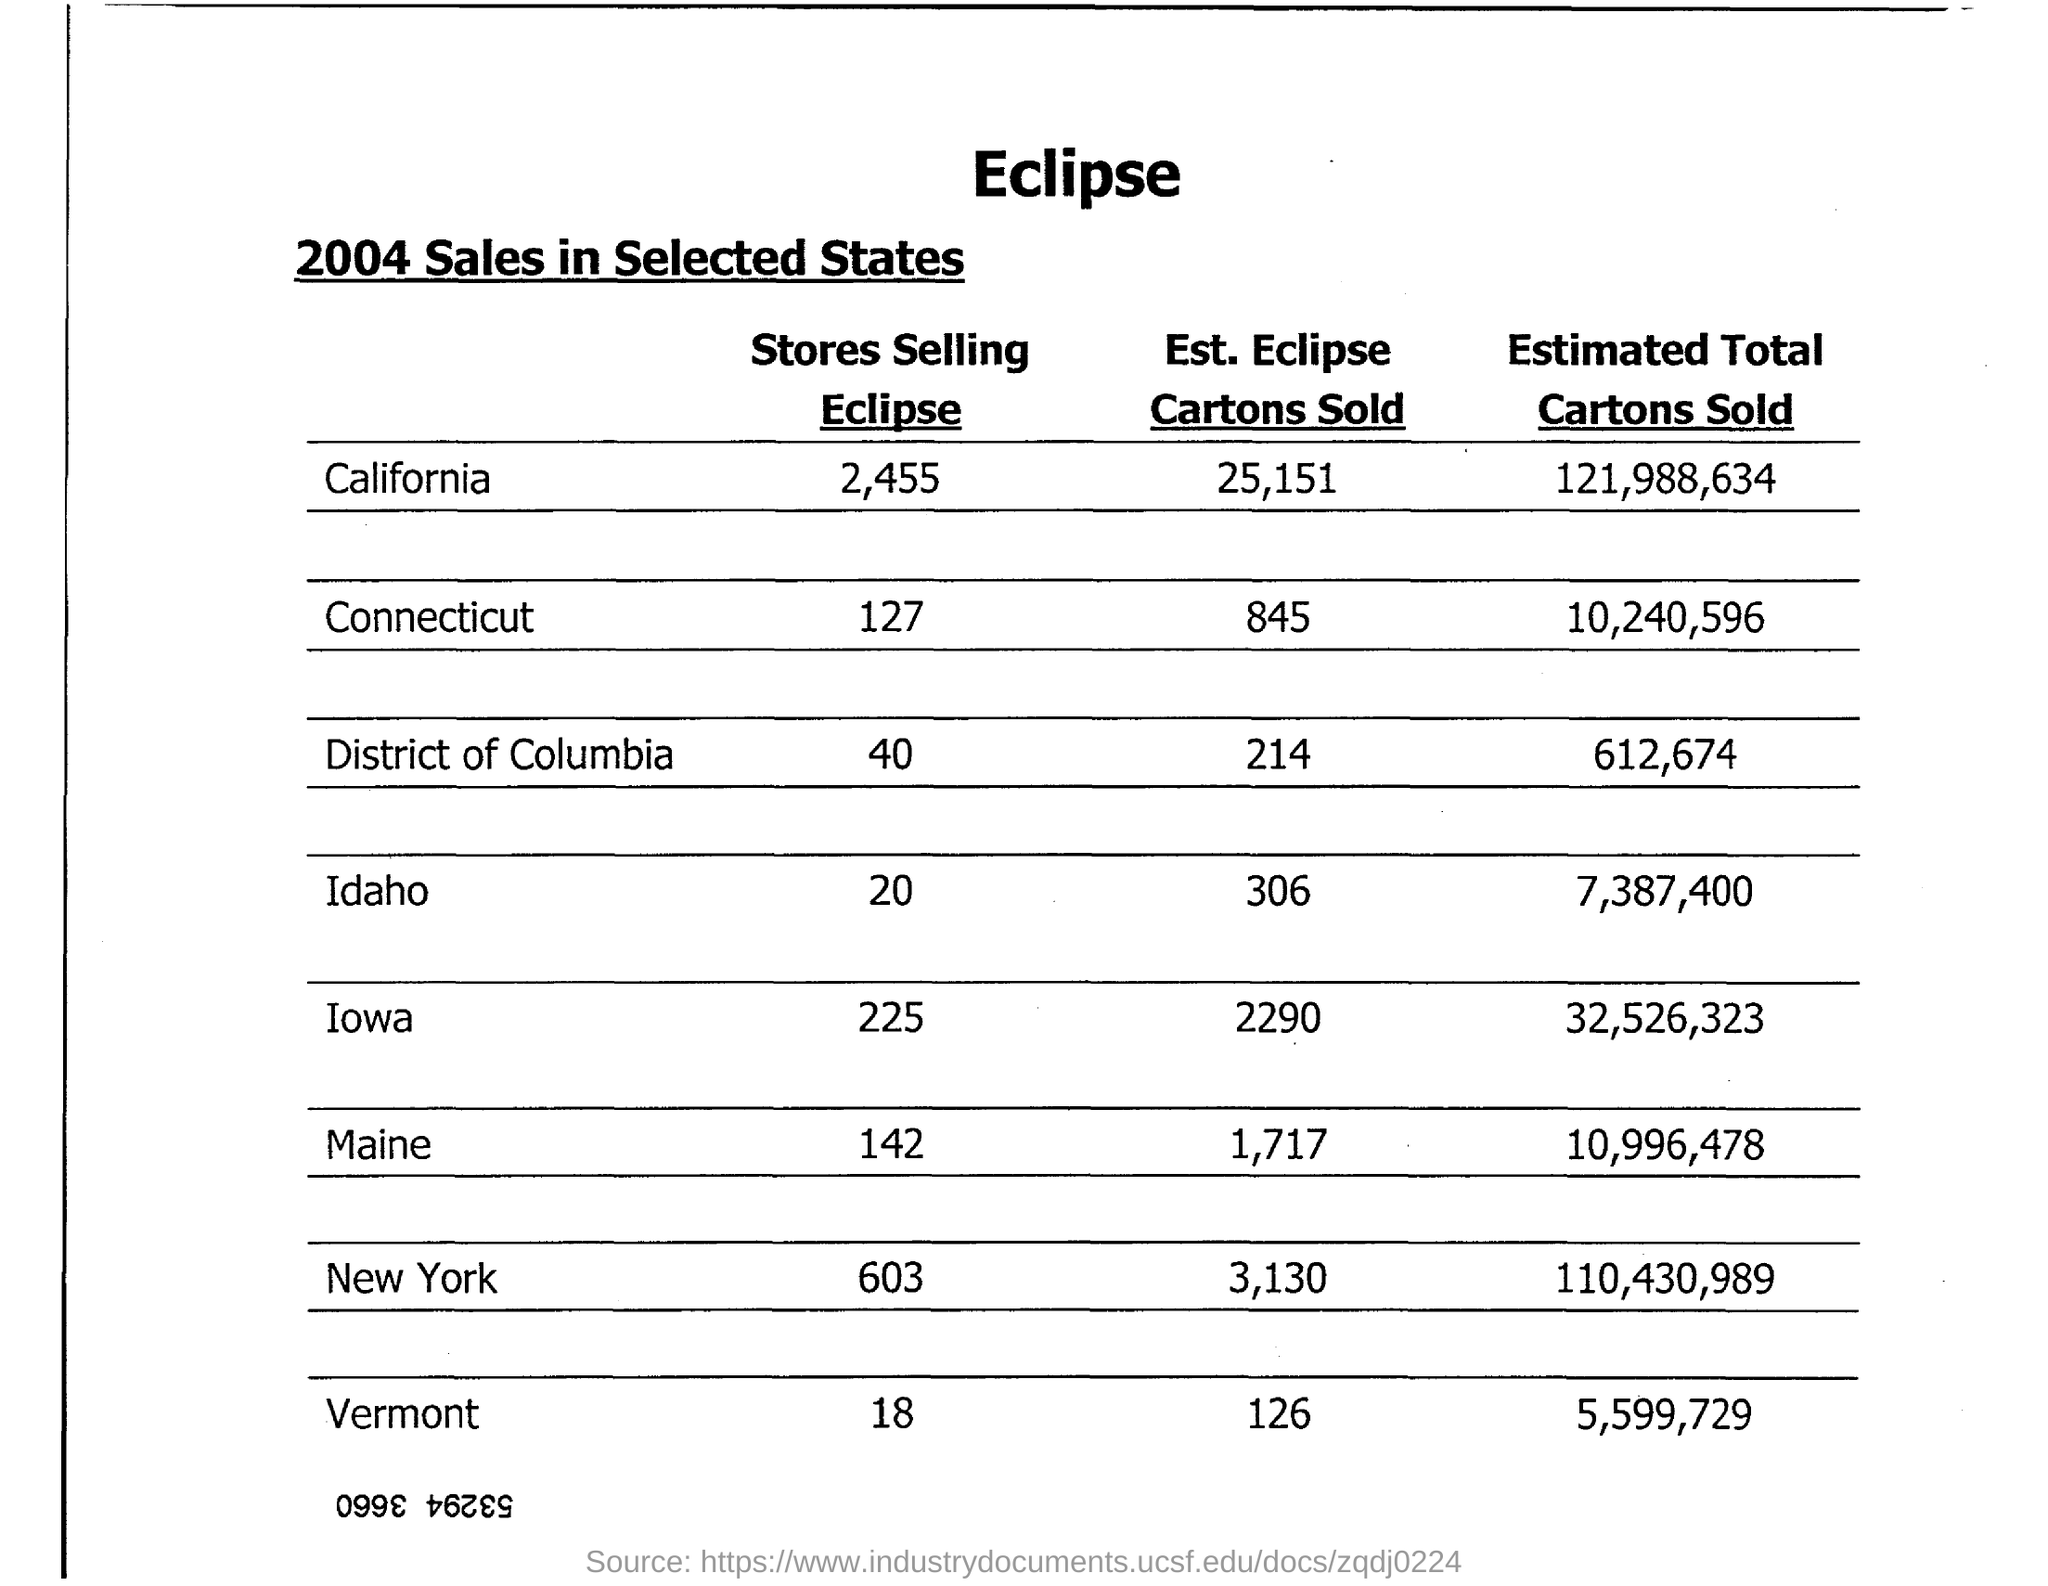Mention a couple of crucial points in this snapshot. Approximately 5,599,729 cartons of food and beverages are expected to be sold in Vermont. It is estimated that approximately 306 Eclipse cartons will be sold in Idaho. The estimated total number of cartons sold in Maine is approximately 10,996,478. It is estimated that approximately 25,151 cartons of Eclipse will be sold in California. 